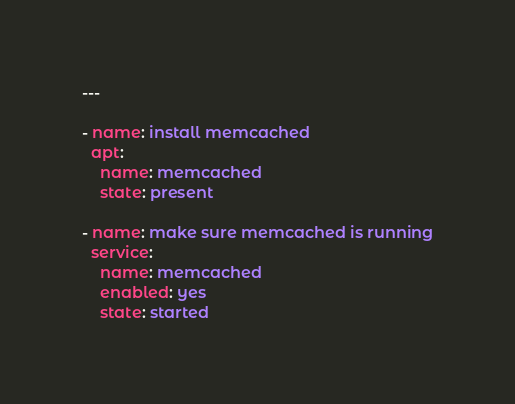Convert code to text. <code><loc_0><loc_0><loc_500><loc_500><_YAML_>---

- name: install memcached
  apt:
    name: memcached
    state: present

- name: make sure memcached is running
  service:
    name: memcached
    enabled: yes
    state: started
</code> 